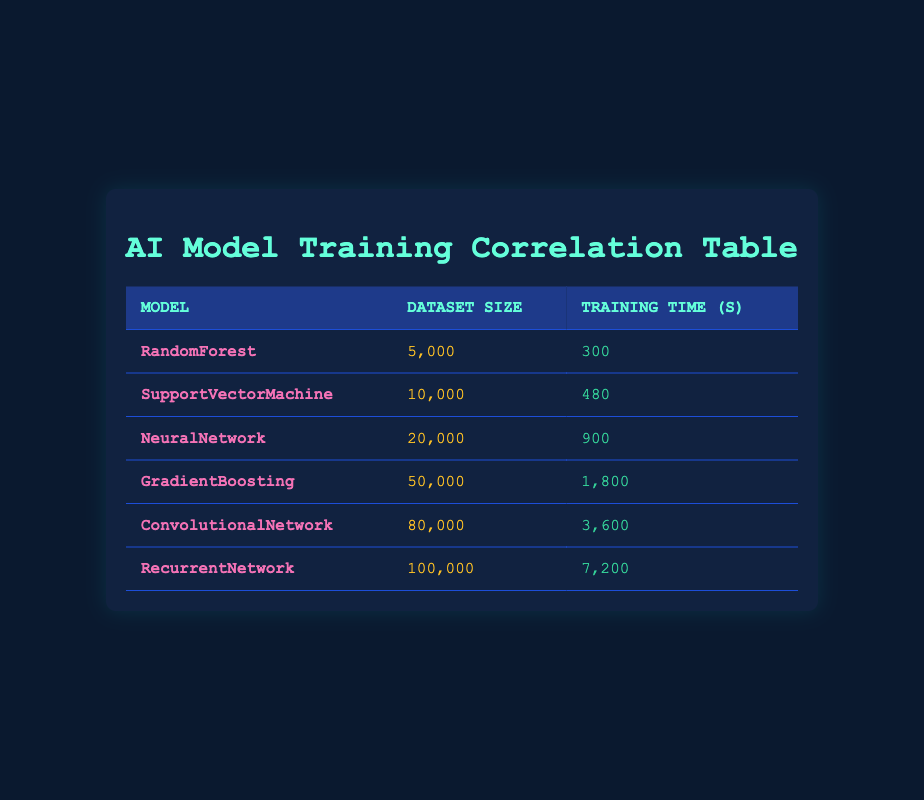What is the training time for the Convolutional Network model? The table indicates that the training time for the Convolutional Network model is shown directly in the corresponding row, which lists it as 3,600 seconds.
Answer: 3,600 seconds Which model has the largest dataset size, and what is that size? By examining the dataset sizes listed for each model, the Recurrent Network model has the largest dataset size of 100,000.
Answer: Recurrent Network, 100,000 What is the average training time across all models? To find the average training time, sum all the training times: (300 + 480 + 900 + 1800 + 3600 + 7200) = 13800 seconds. There are 6 models, so the average is 13800 / 6 = 2300 seconds.
Answer: 2300 seconds Does the Gradient Boosting model have a training time greater than 2,000 seconds? The training time for the Gradient Boosting model is 1,800 seconds, which is less than 2,000 seconds. Hence, the answer is no.
Answer: No What is the increase in training time when moving from the Neural Network model to the Recurrent Network model? The training time for the Neural Network model is 900 seconds, and for the Recurrent Network model, it is 7,200 seconds. The increase is calculated by subtracting 900 from 7200, resulting in 6300 seconds.
Answer: 6300 seconds Is there a model with a dataset size of 50,000? The table confirms that Gradient Boosting has a dataset size of 50,000, so the answer is yes.
Answer: Yes How many seconds does the Random Forest model take for training compared to the Support Vector Machine model? The Random Forest model takes 300 seconds, while the Support Vector Machine model takes 480 seconds. The difference is 480 - 300, which equals 180 seconds.
Answer: 180 seconds What is the total training time for all models combined? By summing the training times from the table: (300 + 480 + 900 + 1800 + 3600 + 7200) = 13800 seconds, which represents the total training time for all models.
Answer: 13800 seconds Which model shows a linear increase in training time based on the dataset size? If we look at the increasing pattern of training time per model, the training times increase consistently with larger dataset sizes, indicating a linear pattern. Therefore, we can conclude that all models show this behavior.
Answer: All models 